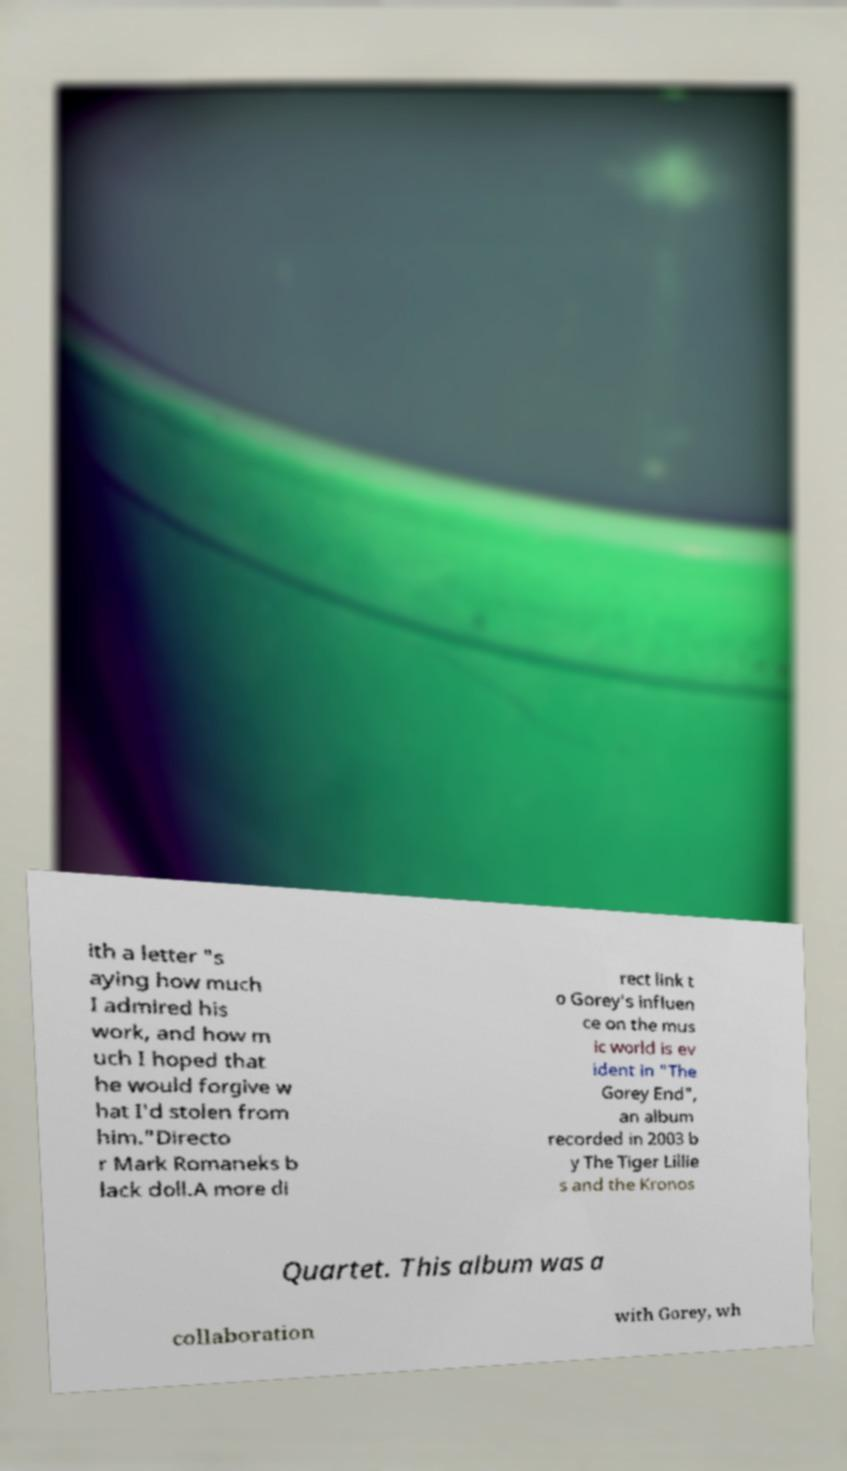I need the written content from this picture converted into text. Can you do that? ith a letter "s aying how much I admired his work, and how m uch I hoped that he would forgive w hat I'd stolen from him."Directo r Mark Romaneks b lack doll.A more di rect link t o Gorey's influen ce on the mus ic world is ev ident in "The Gorey End", an album recorded in 2003 b y The Tiger Lillie s and the Kronos Quartet. This album was a collaboration with Gorey, wh 